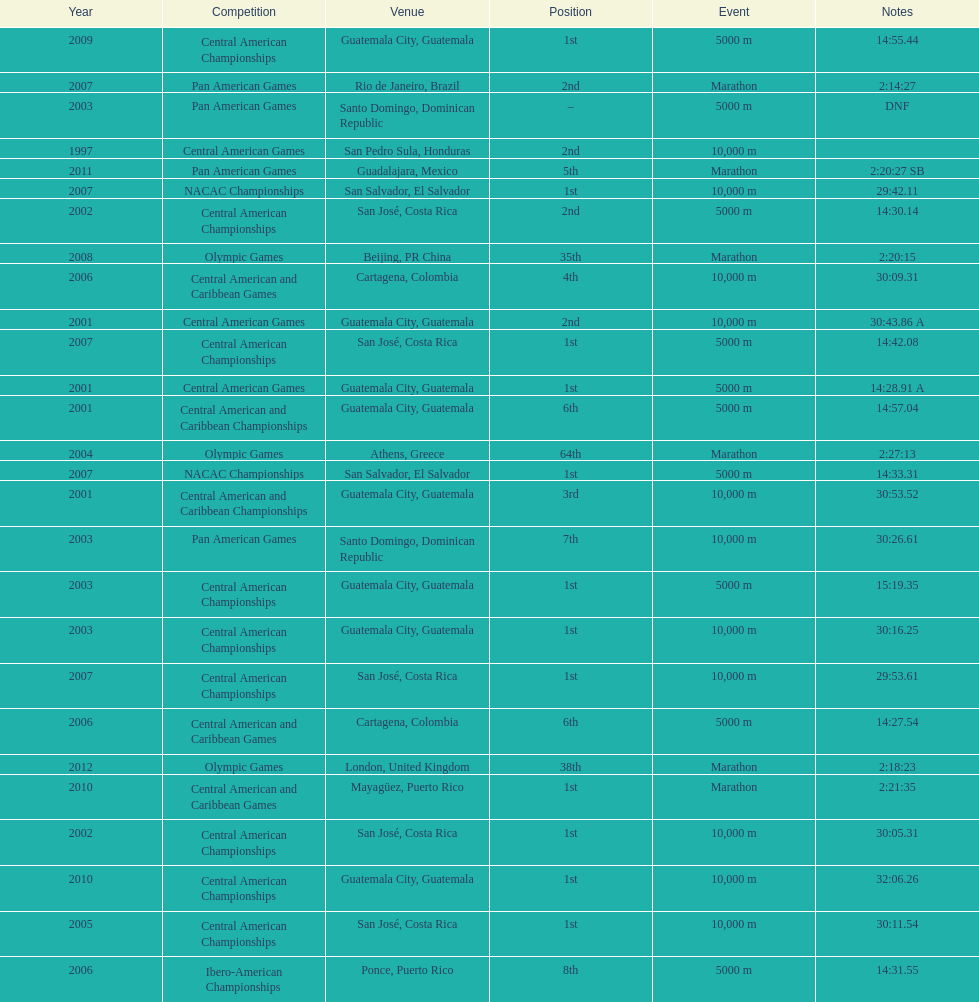What was the first competition this competitor competed in? Central American Games. 